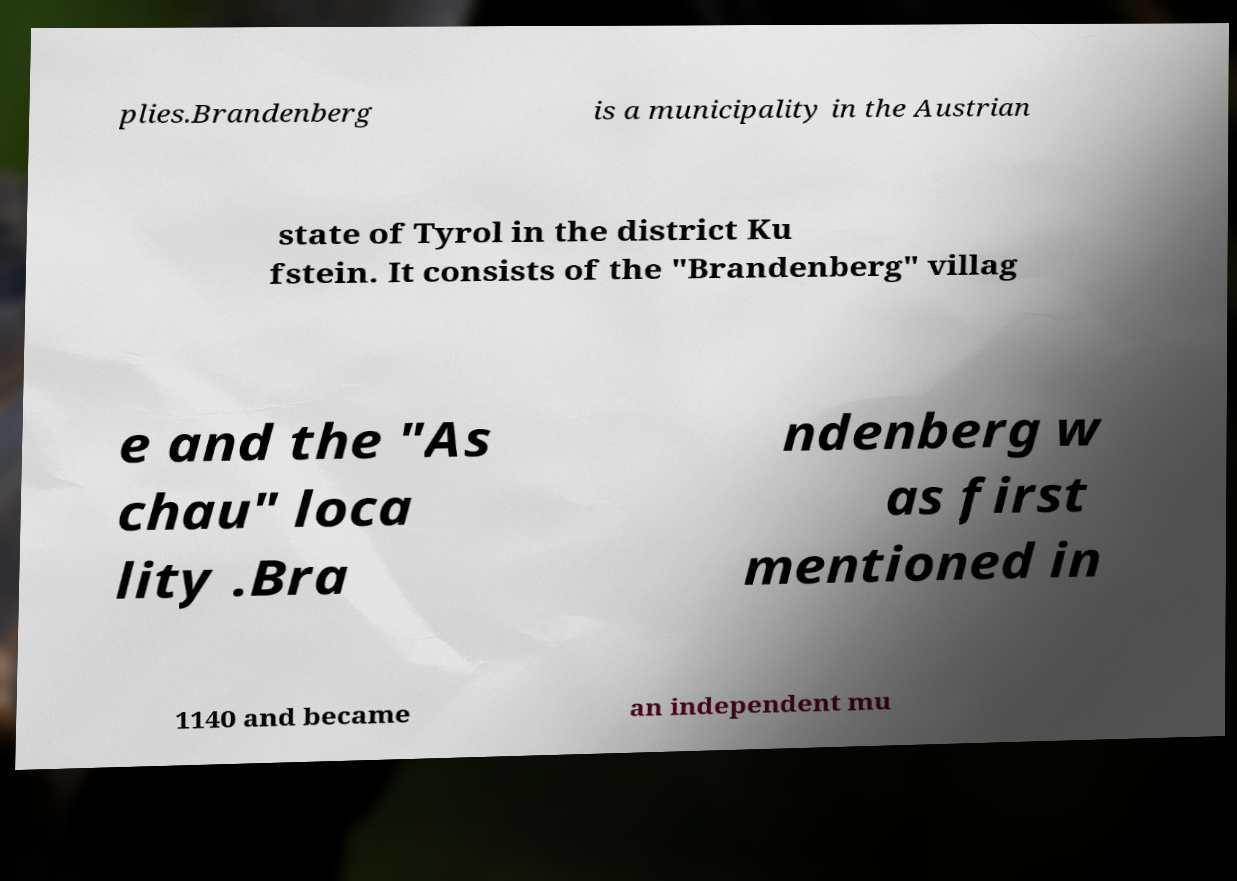Can you read and provide the text displayed in the image?This photo seems to have some interesting text. Can you extract and type it out for me? plies.Brandenberg is a municipality in the Austrian state of Tyrol in the district Ku fstein. It consists of the "Brandenberg" villag e and the "As chau" loca lity .Bra ndenberg w as first mentioned in 1140 and became an independent mu 